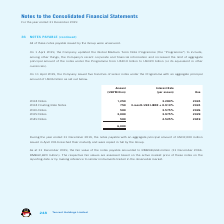According to Tencent's financial document, How much is the aggregate principal amount of the five tranches of senior notes issued under the Programme on 11 April 2019? According to the financial document, USD6 billion. The relevant text states: "amount of USD6 billion as set out below...." Also, How much is the 2024 Notes in USD? According to the financial document, 1,250 (in millions). The relevant text states: "2024 Notes 1,250 3.280% 2024..." Also, How much is the 2026 Notes in USD? According to the financial document, 500 (in millions). The relevant text states: "2026 Notes 500 3.575% 2026..." Also, can you calculate: How many percent of the total notes payable is the 2024 Notes? Based on the calculation: 1,250/6,000, the result is 20.83 (percentage). This is based on the information: "6,000 2024 Notes 1,250 3.280% 2024..." The key data points involved are: 1,250, 6,000. Also, can you calculate: How many percent of the total notes payable is the 2026 Notes? Based on the calculation: 500/6,000, the result is 8.33 (percentage). This is based on the information: "2026 Notes 500 3.575% 2026 6,000..." The key data points involved are: 500, 6,000. Also, can you calculate: How many percent of the total notes payable is the 2029 Notes? Based on the calculation: 3,000/6,000, the result is 50 (percentage). This is based on the information: "6,000 2029 Notes 3,000 3.975% 2029..." The key data points involved are: 3,000, 6,000. 